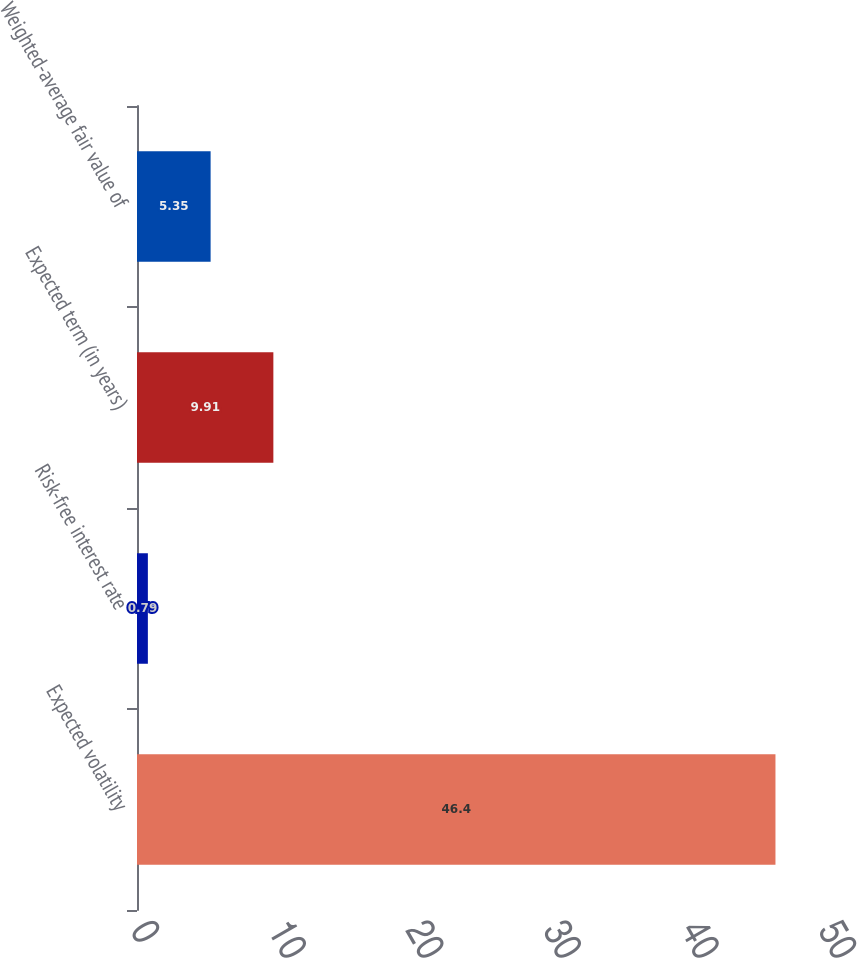Convert chart to OTSL. <chart><loc_0><loc_0><loc_500><loc_500><bar_chart><fcel>Expected volatility<fcel>Risk-free interest rate<fcel>Expected term (in years)<fcel>Weighted-average fair value of<nl><fcel>46.4<fcel>0.79<fcel>9.91<fcel>5.35<nl></chart> 